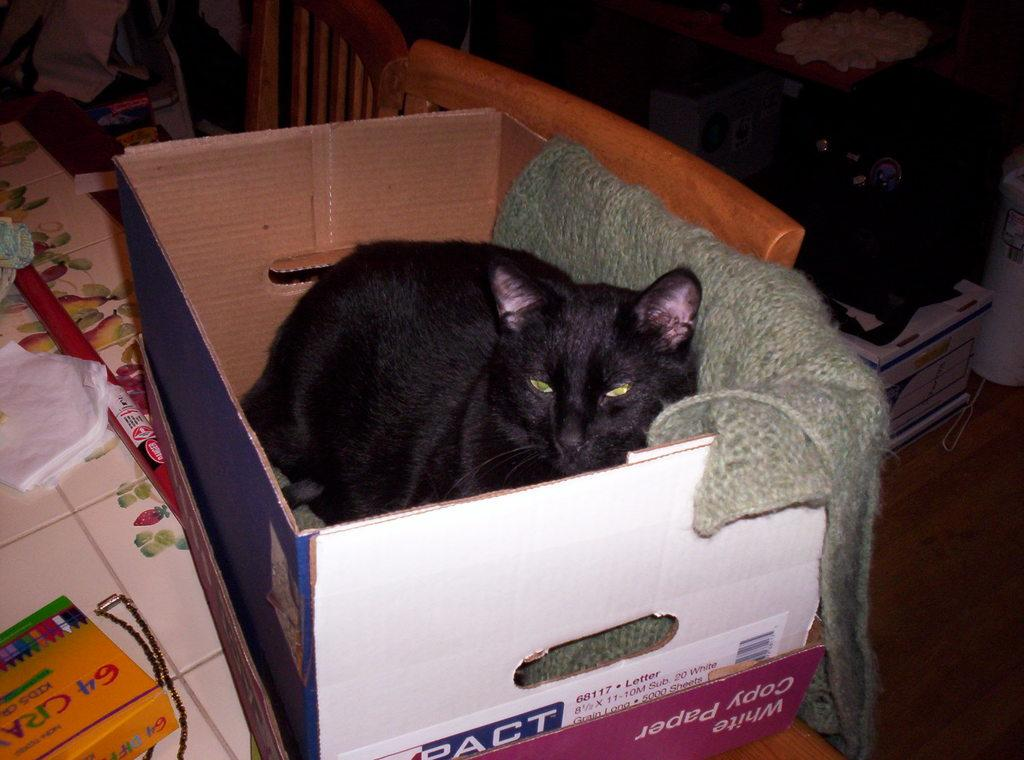<image>
Create a compact narrative representing the image presented. A cat lays in a box that used to contain white copy paper. 